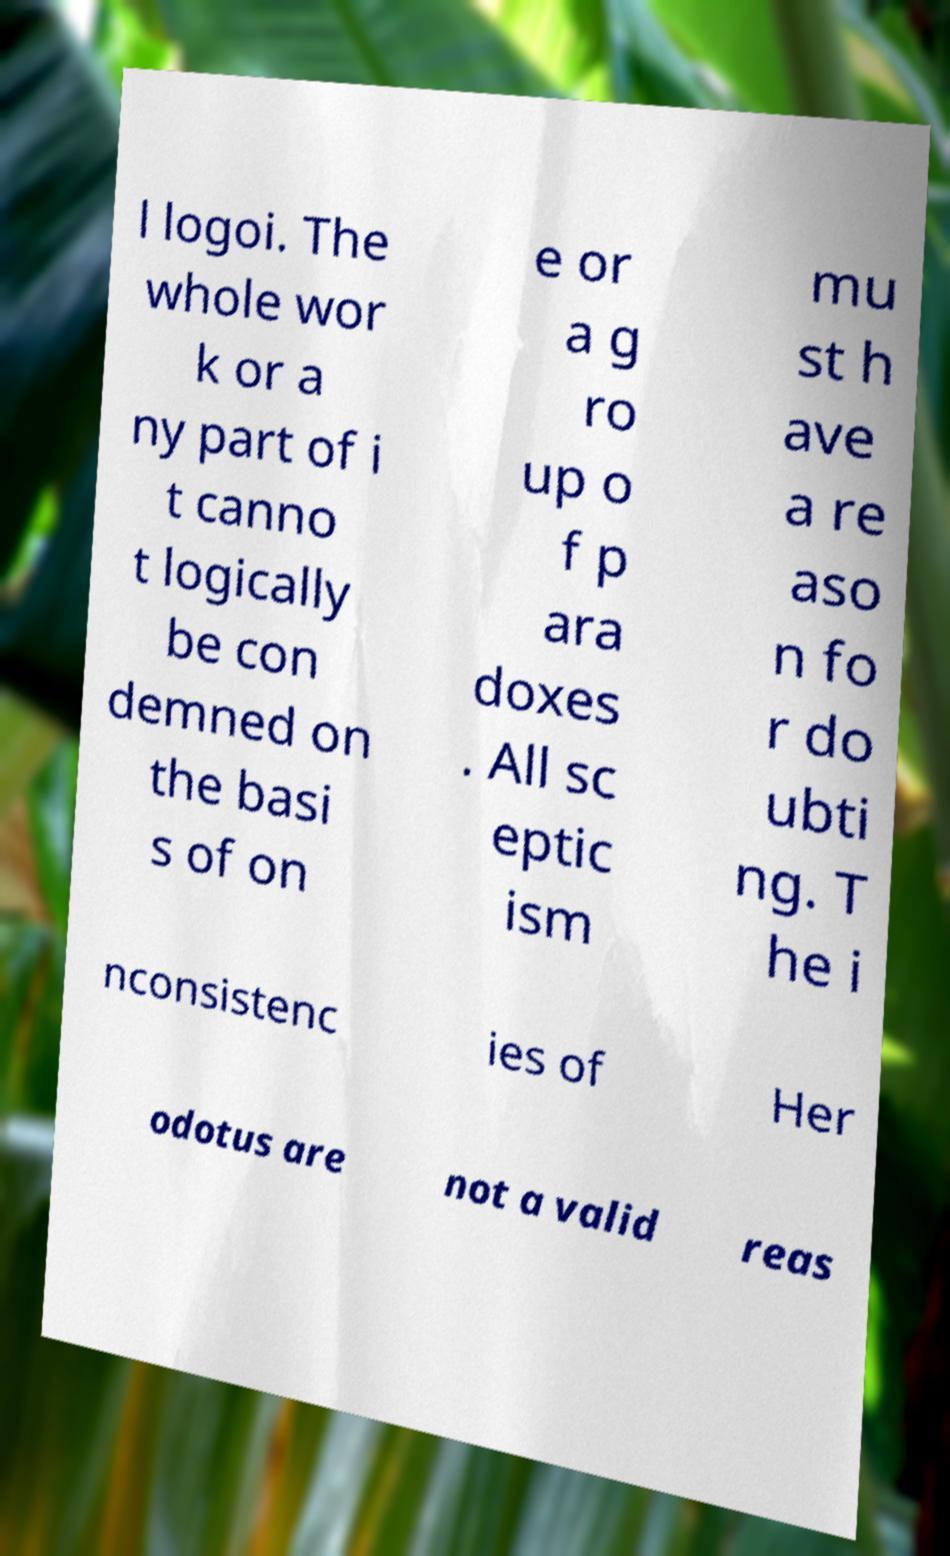There's text embedded in this image that I need extracted. Can you transcribe it verbatim? l logoi. The whole wor k or a ny part of i t canno t logically be con demned on the basi s of on e or a g ro up o f p ara doxes . All sc eptic ism mu st h ave a re aso n fo r do ubti ng. T he i nconsistenc ies of Her odotus are not a valid reas 